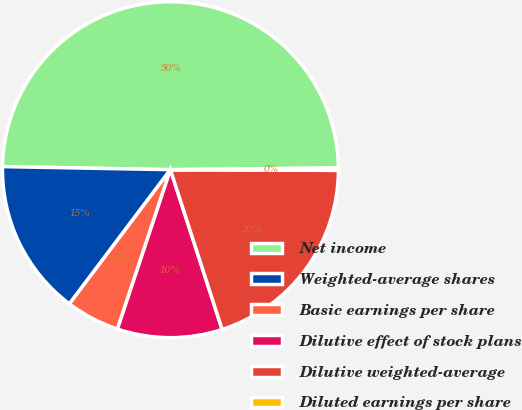Convert chart. <chart><loc_0><loc_0><loc_500><loc_500><pie_chart><fcel>Net income<fcel>Weighted-average shares<fcel>Basic earnings per share<fcel>Dilutive effect of stock plans<fcel>Dilutive weighted-average<fcel>Diluted earnings per share<nl><fcel>49.54%<fcel>15.02%<fcel>5.16%<fcel>10.09%<fcel>19.95%<fcel>0.23%<nl></chart> 